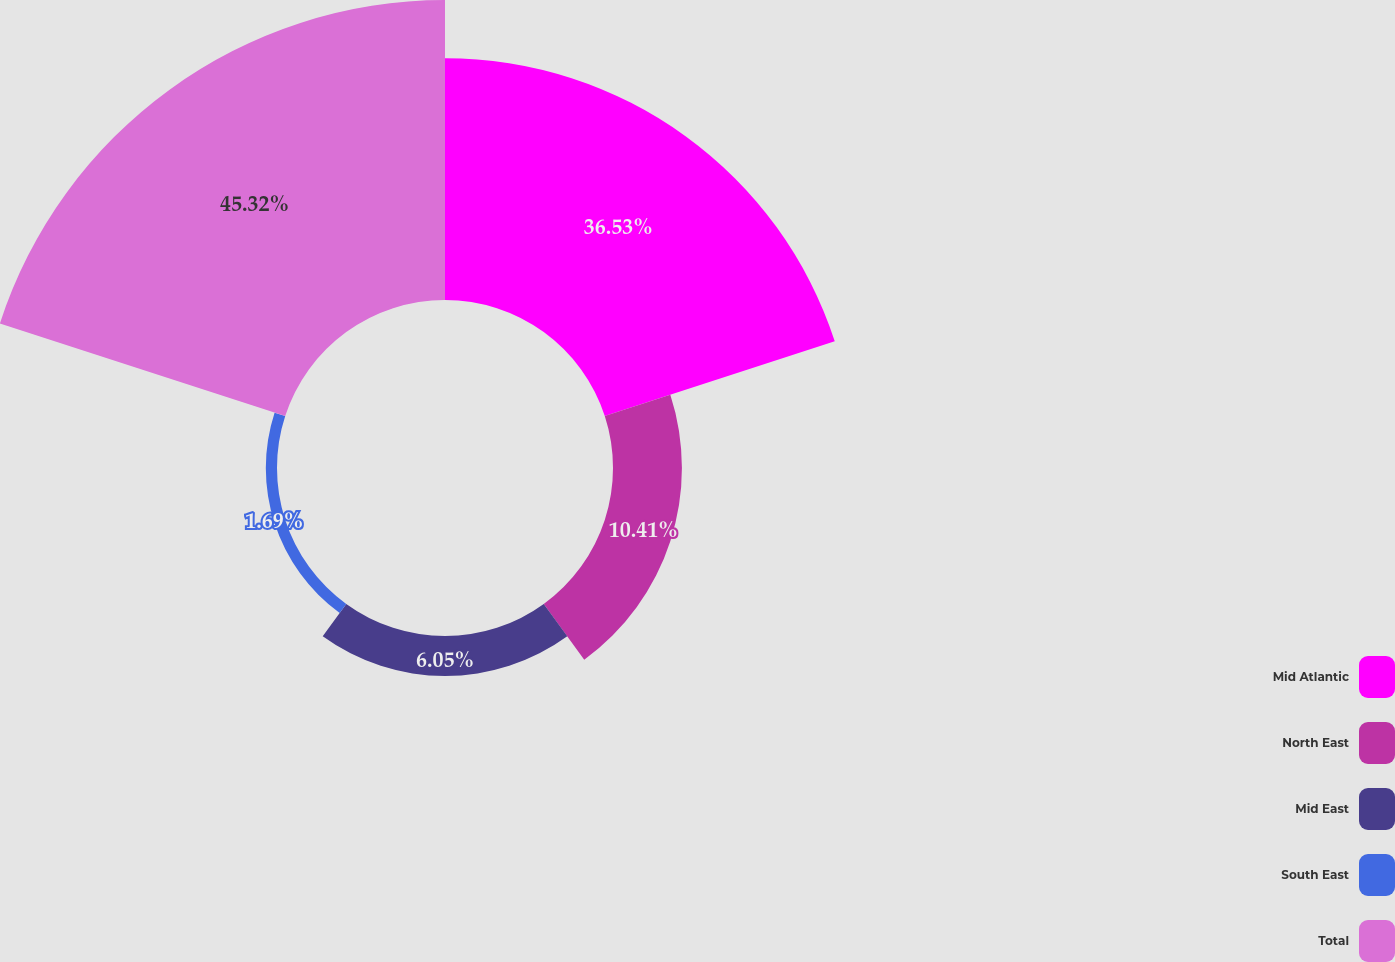<chart> <loc_0><loc_0><loc_500><loc_500><pie_chart><fcel>Mid Atlantic<fcel>North East<fcel>Mid East<fcel>South East<fcel>Total<nl><fcel>36.53%<fcel>10.41%<fcel>6.05%<fcel>1.69%<fcel>45.32%<nl></chart> 